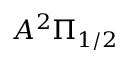Convert formula to latex. <formula><loc_0><loc_0><loc_500><loc_500>A ^ { 2 } \Pi _ { 1 / 2 }</formula> 